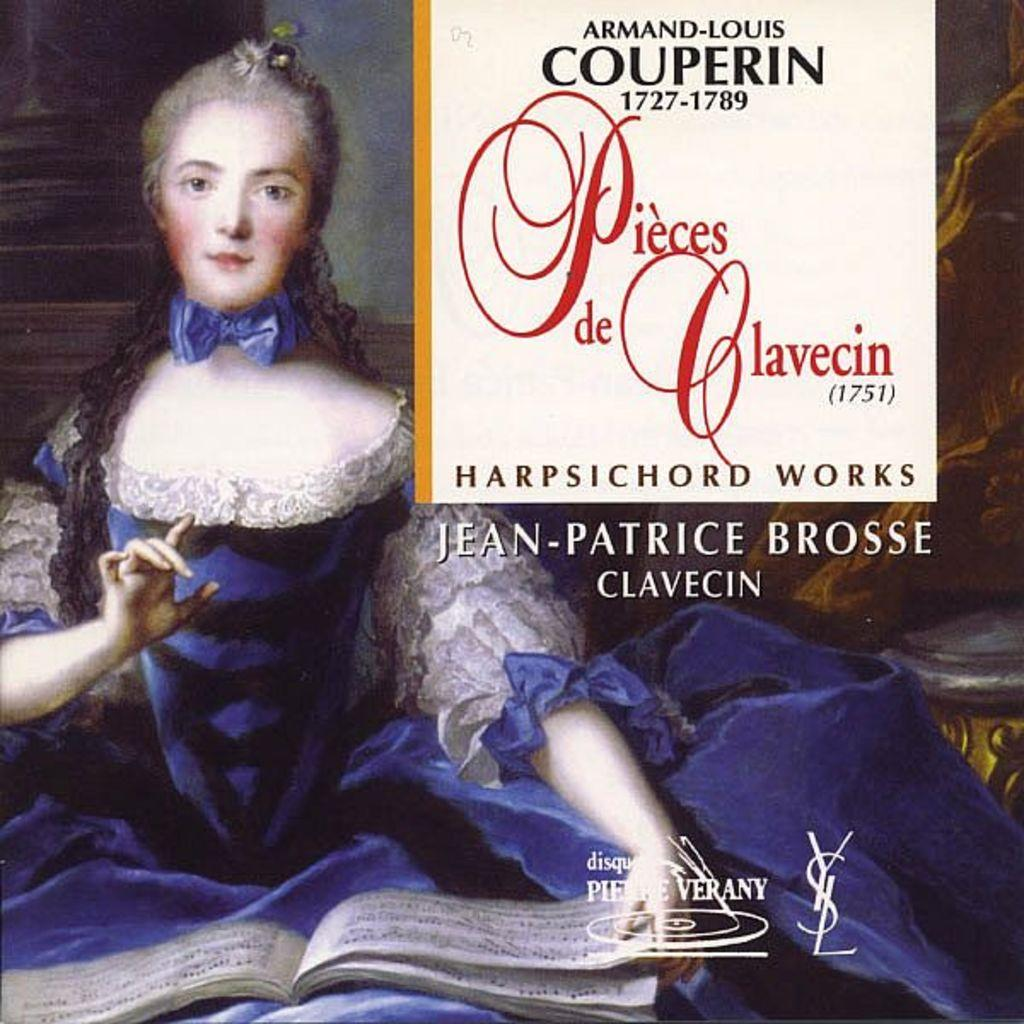<image>
Offer a succinct explanation of the picture presented. cd of harpsichord works called pieces de clavecin 